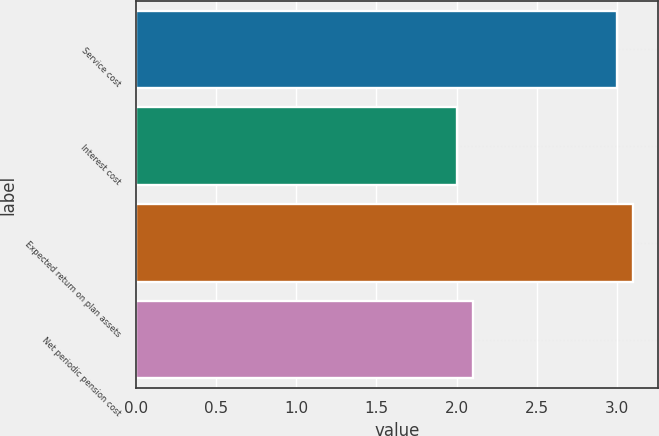Convert chart to OTSL. <chart><loc_0><loc_0><loc_500><loc_500><bar_chart><fcel>Service cost<fcel>Interest cost<fcel>Expected return on plan assets<fcel>Net periodic pension cost<nl><fcel>3<fcel>2<fcel>3.1<fcel>2.1<nl></chart> 